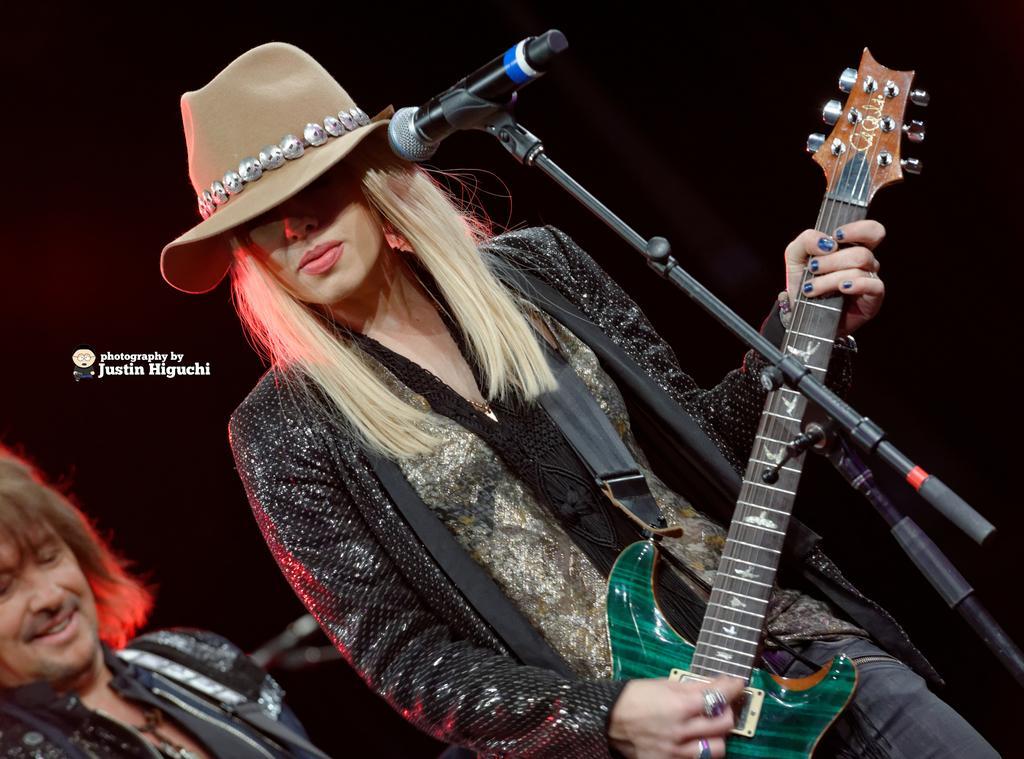Could you give a brief overview of what you see in this image? In the picture we can see a lady playing guitar. There is a microphone in front of her which is attached to a stand. She is wearing a hat. She is wearing a black jacket. there is person in the bottom left corner he is wearing black jacket. He is smiling. 